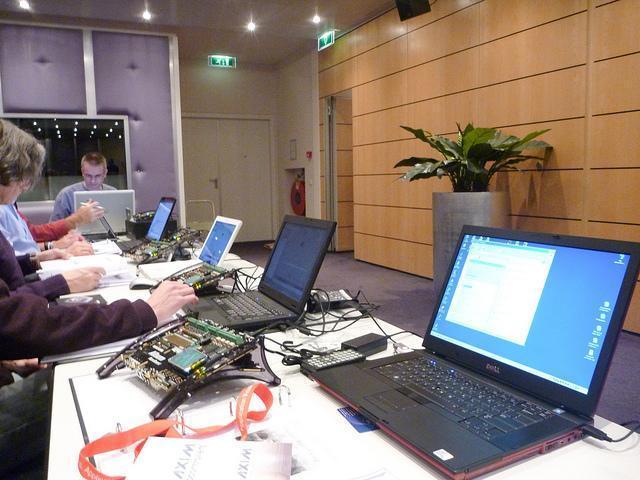How many laptops are there?
Give a very brief answer. 5. 